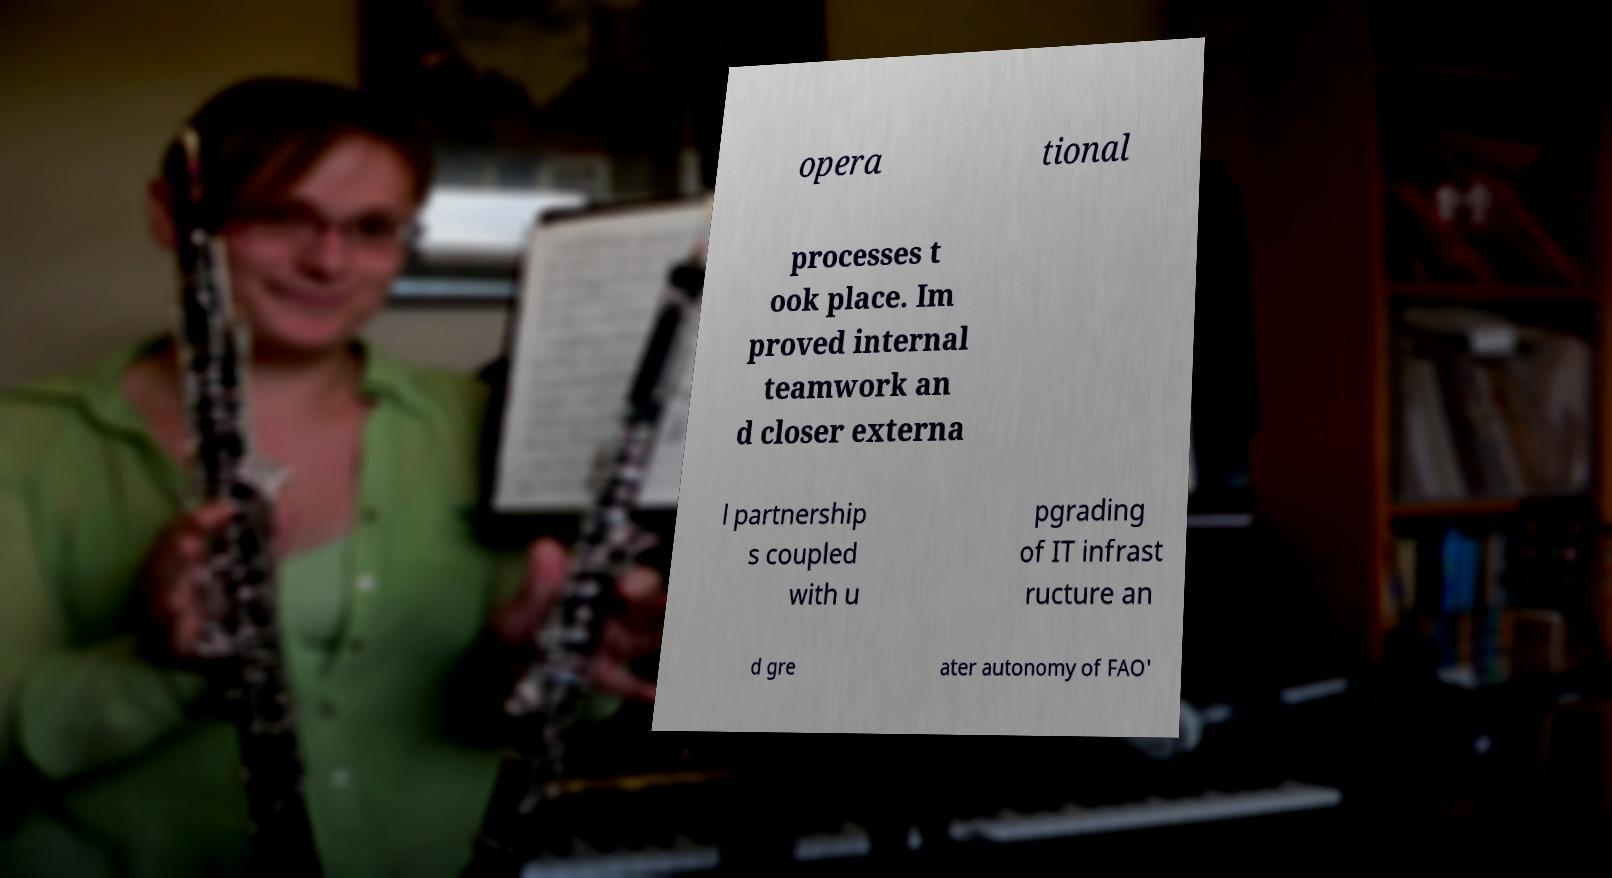Can you accurately transcribe the text from the provided image for me? opera tional processes t ook place. Im proved internal teamwork an d closer externa l partnership s coupled with u pgrading of IT infrast ructure an d gre ater autonomy of FAO' 